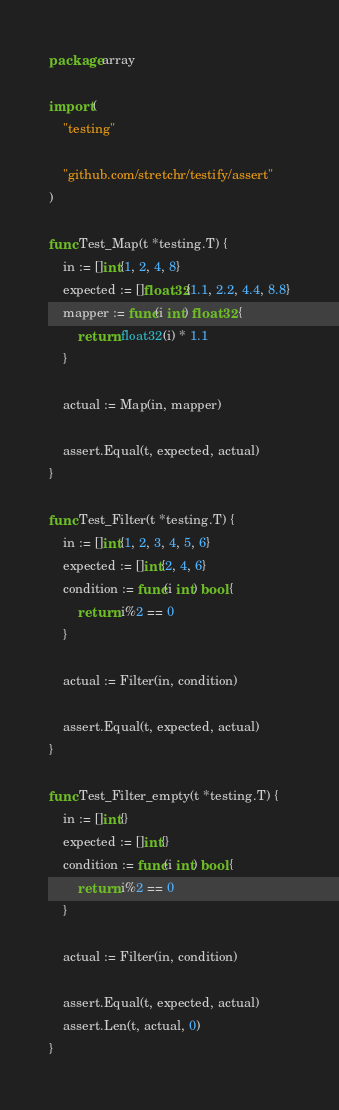Convert code to text. <code><loc_0><loc_0><loc_500><loc_500><_Go_>package array

import (
	"testing"

	"github.com/stretchr/testify/assert"
)

func Test_Map(t *testing.T) {
	in := []int{1, 2, 4, 8}
	expected := []float32{1.1, 2.2, 4.4, 8.8}
	mapper := func(i int) float32 {
		return float32(i) * 1.1
	}

	actual := Map(in, mapper)

	assert.Equal(t, expected, actual)
}

func Test_Filter(t *testing.T) {
	in := []int{1, 2, 3, 4, 5, 6}
	expected := []int{2, 4, 6}
	condition := func(i int) bool {
		return i%2 == 0
	}

	actual := Filter(in, condition)

	assert.Equal(t, expected, actual)
}

func Test_Filter_empty(t *testing.T) {
	in := []int{}
	expected := []int{}
	condition := func(i int) bool {
		return i%2 == 0
	}

	actual := Filter(in, condition)

	assert.Equal(t, expected, actual)
	assert.Len(t, actual, 0)
}
</code> 